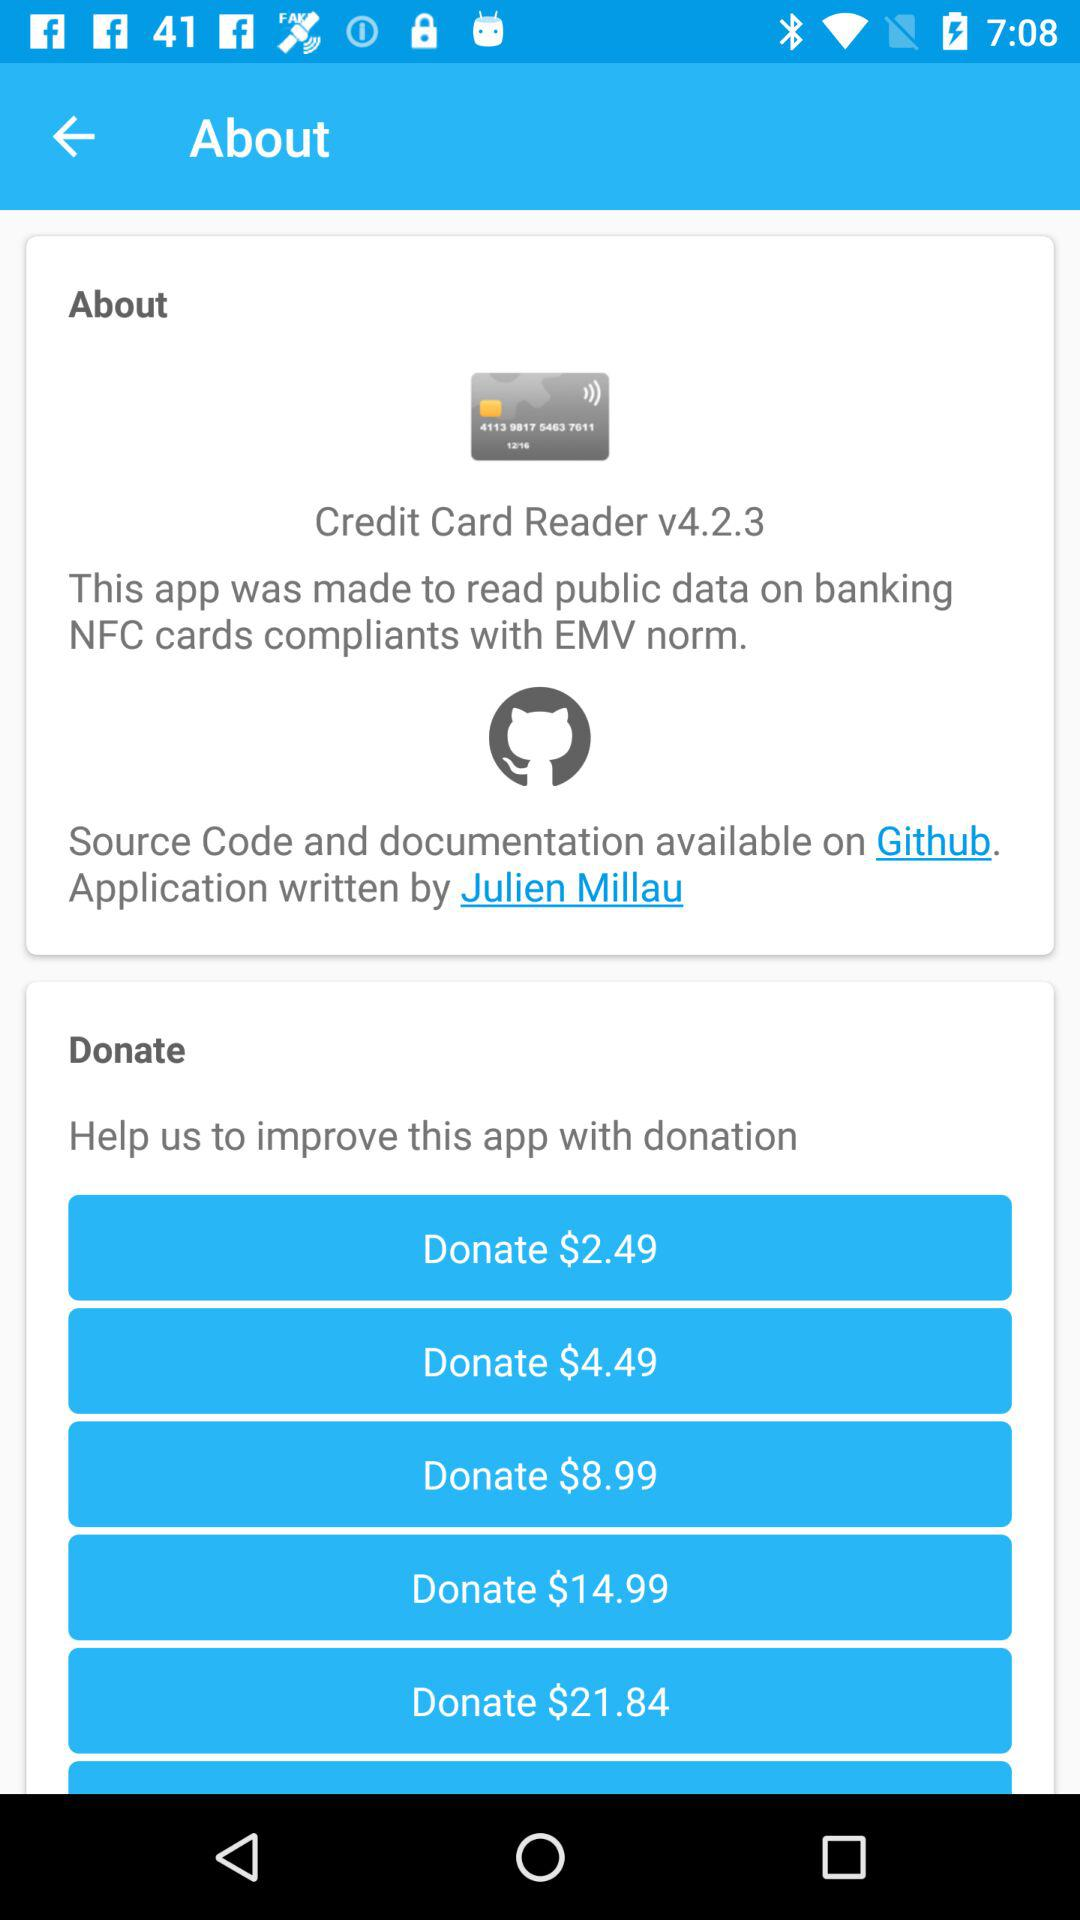What is the currency of donation amount? The currency of donation amount is dollars. 